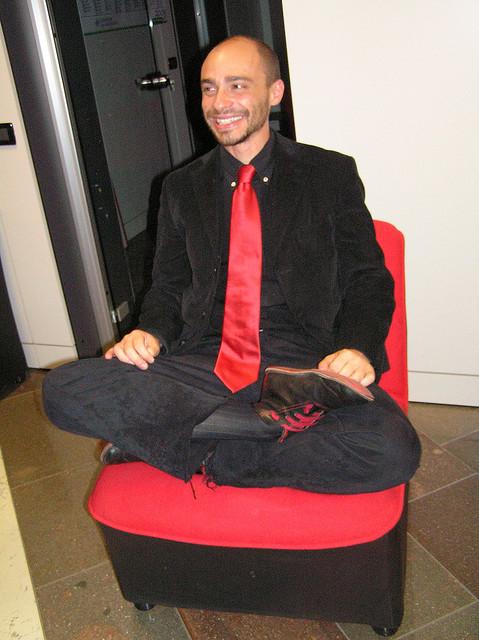What is on the floor next to the man?
Short answer required. Nothing. What color is the top of the chair?
Be succinct. Red. What material is the man's tie made of?
Give a very brief answer. Silk. What material is the floor?
Write a very short answer. Tile. 